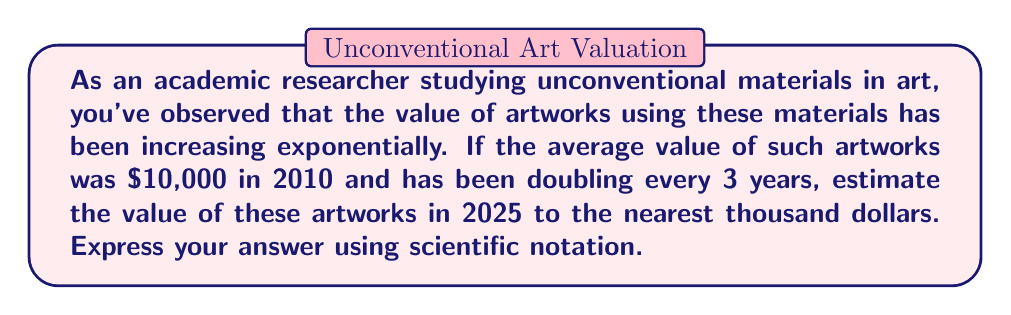Provide a solution to this math problem. To solve this problem, we need to follow these steps:

1. Determine the number of 3-year periods between 2010 and 2025:
   (2025 - 2010) ÷ 3 = 5 periods

2. Use the exponential growth formula:
   $A = P \cdot r^n$
   Where:
   $A$ = final amount
   $P$ = initial principal balance
   $r$ = growth rate (in this case, 2 for doubling)
   $n$ = number of periods

3. Plug in the values:
   $A = 10,000 \cdot 2^5$

4. Calculate:
   $A = 10,000 \cdot 32$
   $A = 320,000$

5. Round to the nearest thousand:
   $320,000$

6. Express in scientific notation:
   $3.2 \times 10^5$
Answer: $3.2 \times 10^5$ dollars 